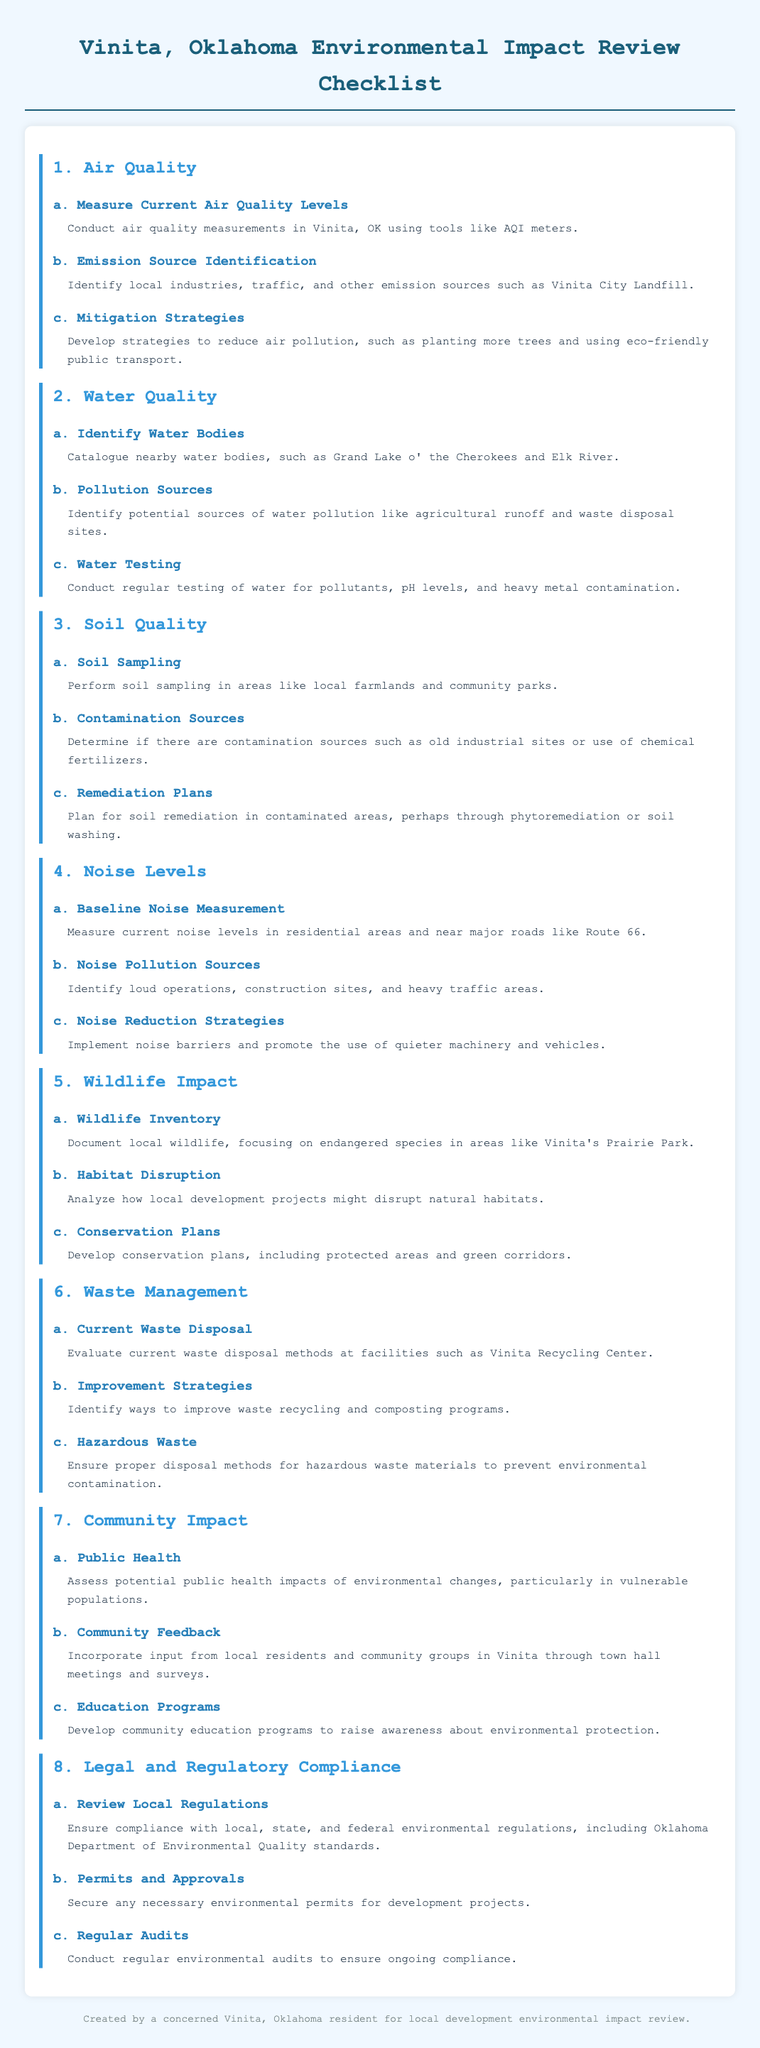what are the three main categories covered in the checklist? The checklist covers eight categories: Air Quality, Water Quality, Soil Quality, Noise Levels, Wildlife Impact, Waste Management, Community Impact, and Legal and Regulatory Compliance.
Answer: Air Quality, Water Quality, Soil Quality what is one identified source of air emissions in Vinita? The checklist mentions the Vinita City Landfill as an emission source.
Answer: Vinita City Landfill which water body is catalogued in the checklist? The checklist includes the Grand Lake o' the Cherokees as a nearby water body.
Answer: Grand Lake o' the Cherokees what is a recommended strategy for mitigating air pollution? The checklist suggests planting more trees as a strategy to reduce air pollution.
Answer: Planting more trees what type of wildlife should be documented according to the checklist? The checklist emphasizes documenting endangered species as part of the wildlife inventory.
Answer: Endangered species what does the checklist suggest about hazardous waste? The checklist states that proper disposal methods for hazardous waste materials should be ensured.
Answer: Proper disposal methods how should community feedback be collected? The checklist advocates for gathering community feedback through town hall meetings and surveys.
Answer: Town hall meetings and surveys what is one legal requirement mentioned in the checklist for development projects? The checklist indicates that securing necessary environmental permits is crucial for development projects.
Answer: Securing necessary environmental permits what is the approach to address contamination in local soils? The checklist suggests planning for soil remediation in contaminated areas, such as through phytoremediation.
Answer: Soil remediation 